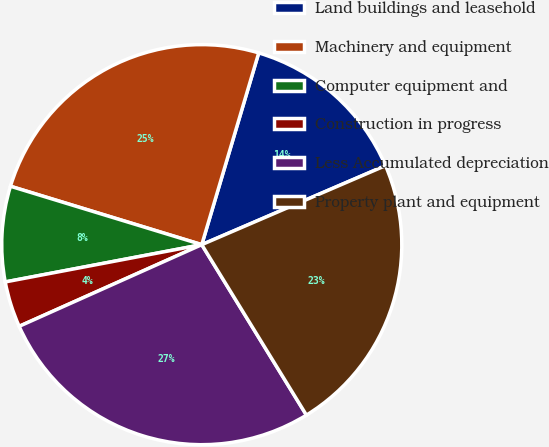Convert chart to OTSL. <chart><loc_0><loc_0><loc_500><loc_500><pie_chart><fcel>Land buildings and leasehold<fcel>Machinery and equipment<fcel>Computer equipment and<fcel>Construction in progress<fcel>Less Accumulated depreciation<fcel>Property plant and equipment<nl><fcel>13.94%<fcel>24.88%<fcel>7.7%<fcel>3.71%<fcel>27.07%<fcel>22.7%<nl></chart> 